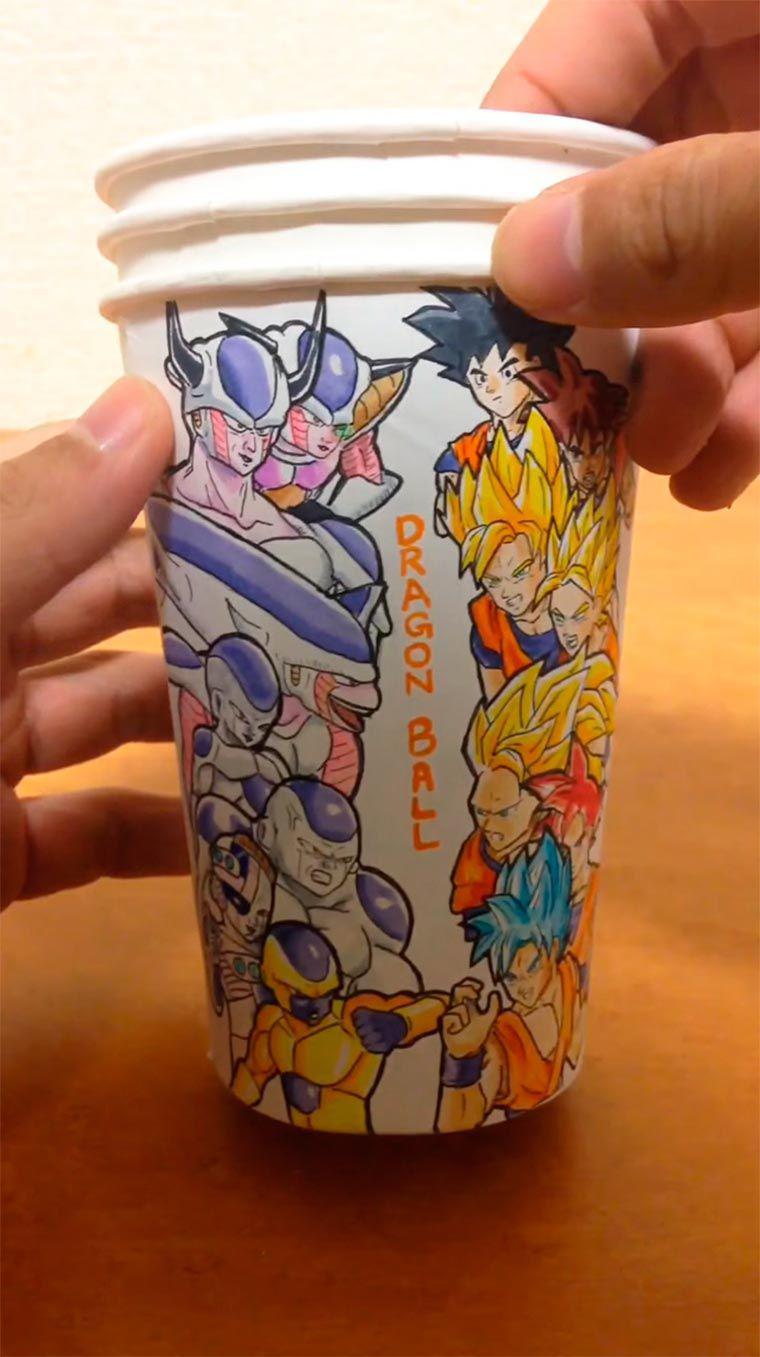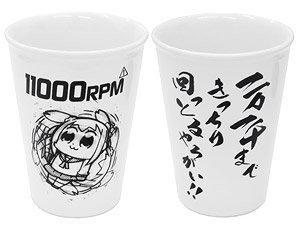The first image is the image on the left, the second image is the image on the right. Analyze the images presented: Is the assertion "In at least one image there are three paper cups." valid? Answer yes or no. Yes. The first image is the image on the left, the second image is the image on the right. Examine the images to the left and right. Is the description "The left image shows a thumb on the left side of a cup, and the right image includes a cup with a cartoon face on it and contains no more than two cups." accurate? Answer yes or no. Yes. 